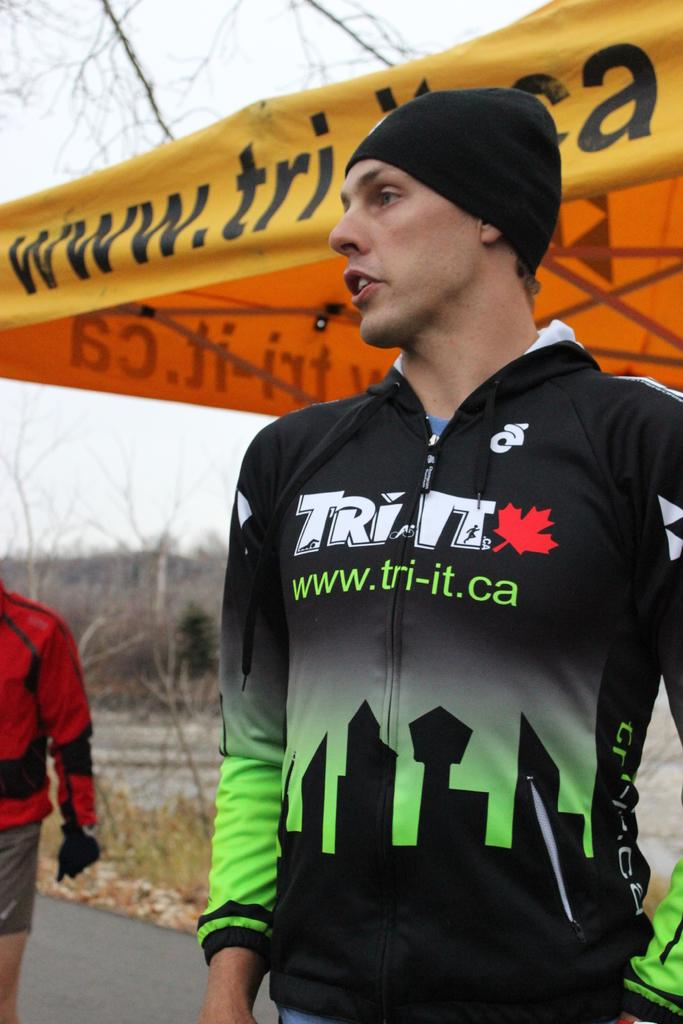Provide a one-sentence caption for the provided image. A man in athletic gears reading Tri-It stands waiting to compete in a race. 